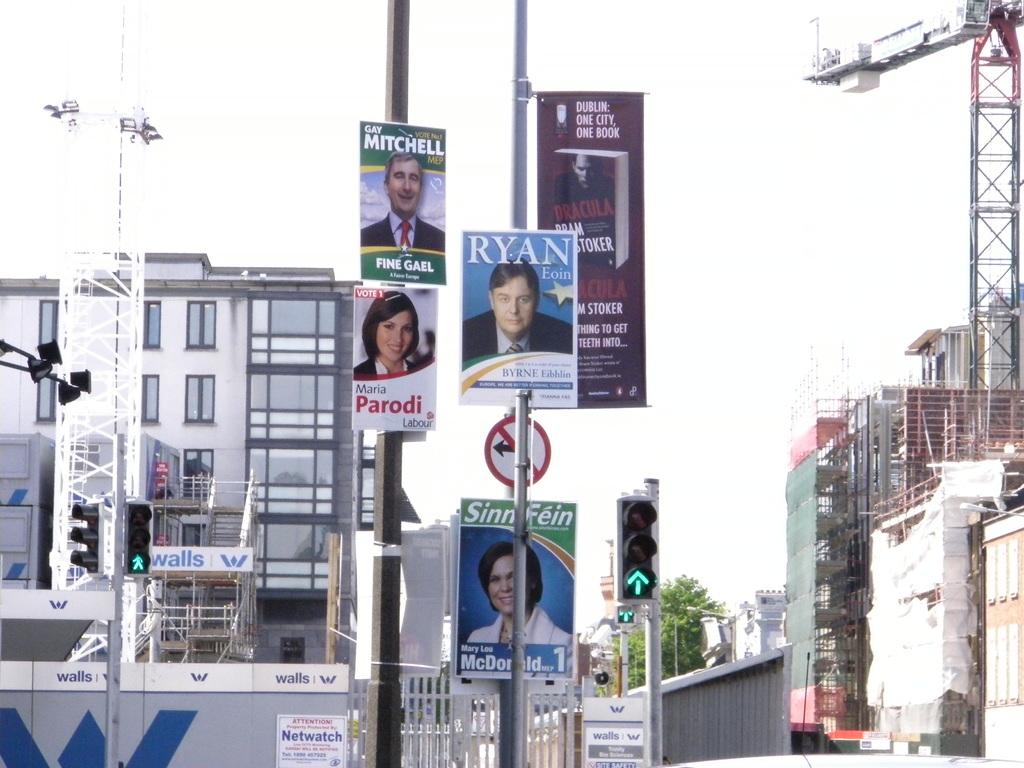What is ryan's last name?
Make the answer very short. Eoin. 